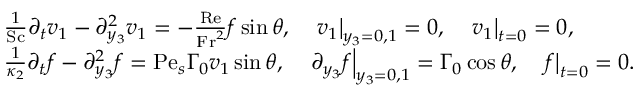Convert formula to latex. <formula><loc_0><loc_0><loc_500><loc_500>\begin{array} { r l } & { \frac { 1 } { S c } \partial _ { t } v _ { 1 } - \partial _ { y _ { 3 } } ^ { 2 } v _ { 1 } = - \frac { R e } { F r ^ { 2 } } f \sin \theta , \quad v _ { 1 } \right | _ { y _ { 3 } = 0 , 1 } = 0 , \quad v _ { 1 } \right | _ { t = 0 } = 0 , } \\ & { \frac { 1 } { \kappa _ { 2 } } \partial _ { t } f - \partial _ { y _ { 3 } } ^ { 2 } f = P e _ { s } \Gamma _ { 0 } v _ { 1 } \sin \theta , \quad \partial _ { y _ { 3 } } f \right | _ { y _ { 3 } = 0 , 1 } = \Gamma _ { 0 } \cos \theta , \quad f \right | _ { t = 0 } = 0 . } \end{array}</formula> 